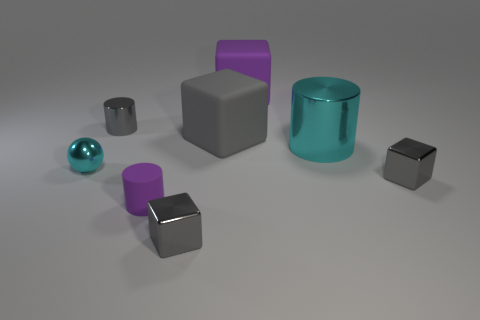Subtract all gray cylinders. How many gray cubes are left? 3 Subtract all green blocks. Subtract all yellow spheres. How many blocks are left? 4 Add 2 purple cubes. How many objects exist? 10 Subtract all cylinders. How many objects are left? 5 Add 8 big cyan matte blocks. How many big cyan matte blocks exist? 8 Subtract 0 brown cylinders. How many objects are left? 8 Subtract all purple blocks. Subtract all balls. How many objects are left? 6 Add 2 small metallic cylinders. How many small metallic cylinders are left? 3 